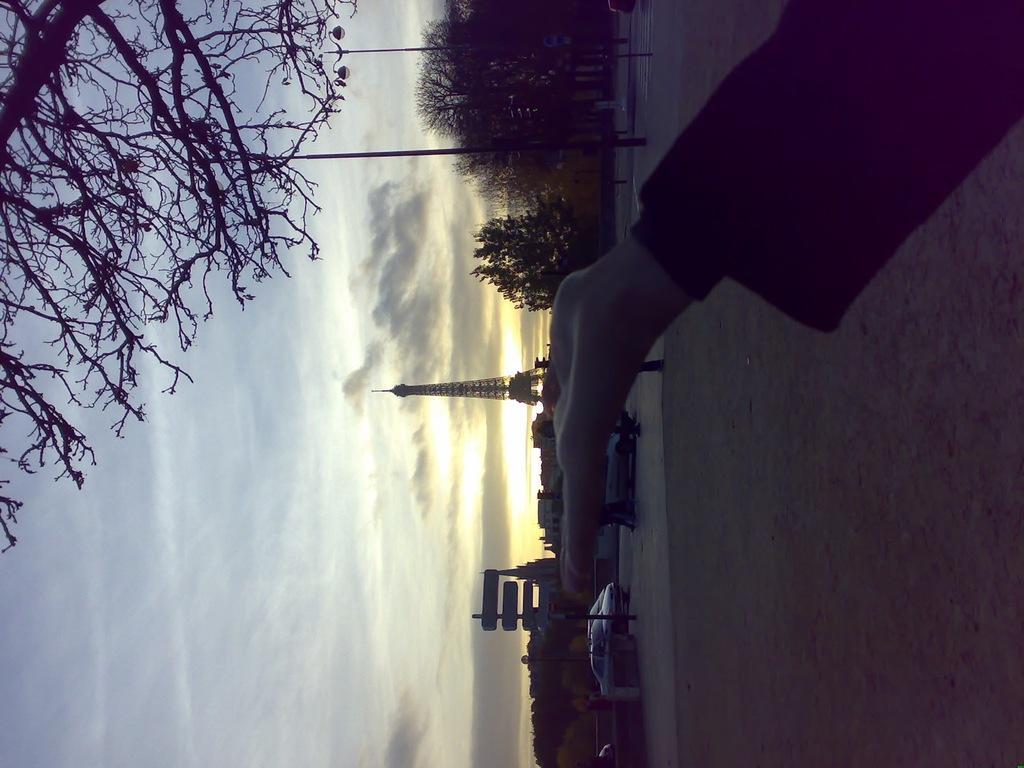Please provide a concise description of this image. In this picture we can see a person's hand and the ground. In the background we can see vehicles, poles, trees, buildings, boards, tower and the sky with clouds. 